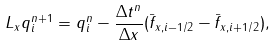Convert formula to latex. <formula><loc_0><loc_0><loc_500><loc_500>L _ { x } q _ { i } ^ { n + 1 } = q _ { i } ^ { n } - \frac { \Delta t ^ { n } } { \Delta x } ( \bar { f } _ { x , i - 1 / 2 } - \bar { f } _ { x , i + 1 / 2 } ) ,</formula> 